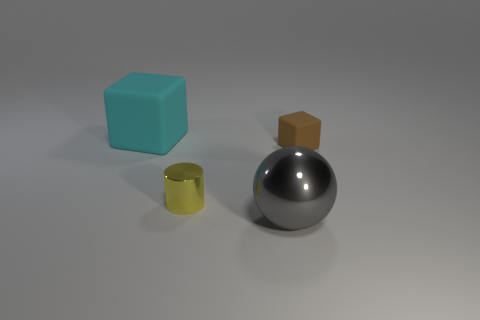What number of yellow objects are big cubes or small metallic objects?
Provide a short and direct response. 1. Are there any other things that are the same material as the big cube?
Provide a short and direct response. Yes. There is a metallic thing behind the big ball; does it have the same shape as the metal thing in front of the small metallic cylinder?
Offer a very short reply. No. What number of yellow metal cylinders are there?
Provide a short and direct response. 1. The tiny object that is the same material as the cyan cube is what shape?
Keep it short and to the point. Cube. Is there anything else that has the same color as the tiny block?
Keep it short and to the point. No. Is the color of the large matte cube the same as the tiny object that is right of the shiny sphere?
Offer a very short reply. No. Is the number of brown matte objects that are on the left side of the large cyan rubber block less than the number of blue matte cylinders?
Your answer should be very brief. No. What is the material of the cube on the right side of the shiny sphere?
Your answer should be compact. Rubber. How many other things are there of the same size as the cylinder?
Provide a succinct answer. 1. 